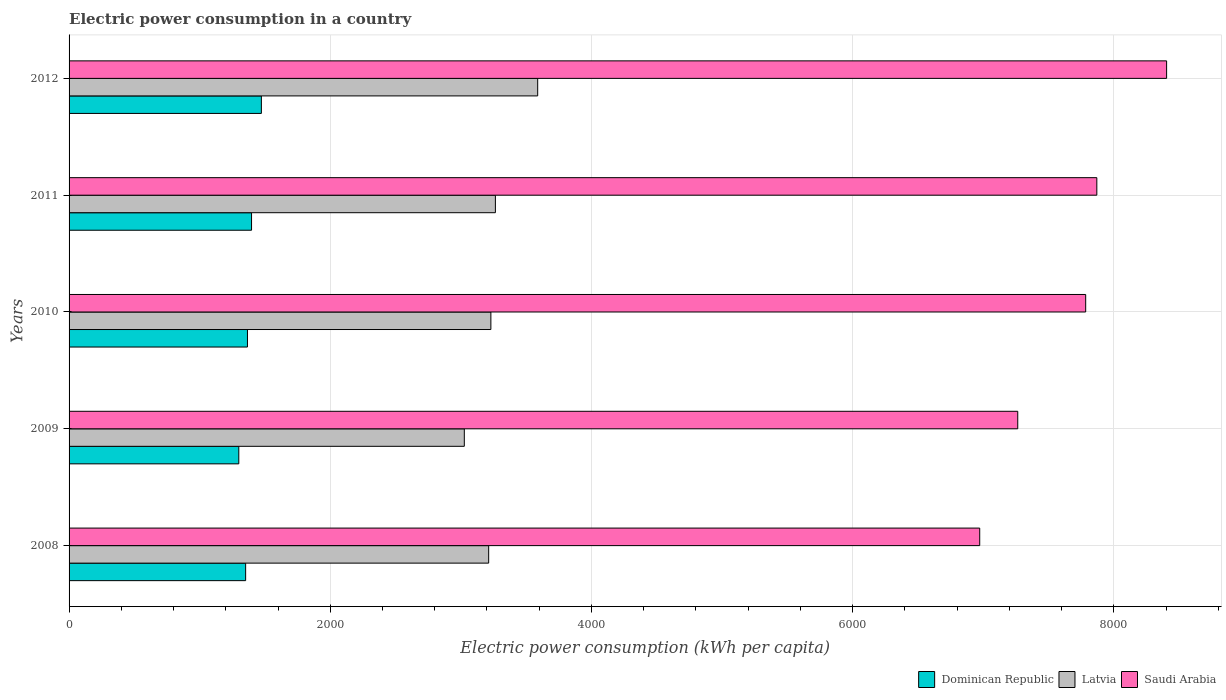How many bars are there on the 4th tick from the top?
Provide a short and direct response. 3. What is the electric power consumption in in Latvia in 2009?
Provide a short and direct response. 3026.61. Across all years, what is the maximum electric power consumption in in Latvia?
Your answer should be compact. 3588.42. Across all years, what is the minimum electric power consumption in in Saudi Arabia?
Your answer should be compact. 6973.38. What is the total electric power consumption in in Latvia in the graph?
Offer a very short reply. 1.63e+04. What is the difference between the electric power consumption in in Dominican Republic in 2010 and that in 2011?
Offer a very short reply. -31.27. What is the difference between the electric power consumption in in Latvia in 2010 and the electric power consumption in in Dominican Republic in 2008?
Your answer should be very brief. 1877.8. What is the average electric power consumption in in Latvia per year?
Your answer should be compact. 3264.53. In the year 2009, what is the difference between the electric power consumption in in Latvia and electric power consumption in in Dominican Republic?
Give a very brief answer. 1726.92. In how many years, is the electric power consumption in in Saudi Arabia greater than 4800 kWh per capita?
Your response must be concise. 5. What is the ratio of the electric power consumption in in Dominican Republic in 2009 to that in 2010?
Give a very brief answer. 0.95. Is the difference between the electric power consumption in in Latvia in 2010 and 2011 greater than the difference between the electric power consumption in in Dominican Republic in 2010 and 2011?
Your answer should be very brief. No. What is the difference between the highest and the second highest electric power consumption in in Dominican Republic?
Your response must be concise. 75.26. What is the difference between the highest and the lowest electric power consumption in in Dominican Republic?
Provide a succinct answer. 172.88. In how many years, is the electric power consumption in in Dominican Republic greater than the average electric power consumption in in Dominican Republic taken over all years?
Give a very brief answer. 2. What does the 3rd bar from the top in 2011 represents?
Provide a succinct answer. Dominican Republic. What does the 3rd bar from the bottom in 2008 represents?
Offer a very short reply. Saudi Arabia. Is it the case that in every year, the sum of the electric power consumption in in Dominican Republic and electric power consumption in in Saudi Arabia is greater than the electric power consumption in in Latvia?
Your response must be concise. Yes. Are the values on the major ticks of X-axis written in scientific E-notation?
Your response must be concise. No. Does the graph contain any zero values?
Provide a short and direct response. No. Where does the legend appear in the graph?
Ensure brevity in your answer.  Bottom right. How many legend labels are there?
Your response must be concise. 3. How are the legend labels stacked?
Your response must be concise. Horizontal. What is the title of the graph?
Ensure brevity in your answer.  Electric power consumption in a country. Does "Switzerland" appear as one of the legend labels in the graph?
Your response must be concise. No. What is the label or title of the X-axis?
Provide a short and direct response. Electric power consumption (kWh per capita). What is the Electric power consumption (kWh per capita) in Dominican Republic in 2008?
Make the answer very short. 1352.15. What is the Electric power consumption (kWh per capita) of Latvia in 2008?
Your answer should be very brief. 3213.12. What is the Electric power consumption (kWh per capita) in Saudi Arabia in 2008?
Offer a terse response. 6973.38. What is the Electric power consumption (kWh per capita) of Dominican Republic in 2009?
Offer a very short reply. 1299.69. What is the Electric power consumption (kWh per capita) of Latvia in 2009?
Give a very brief answer. 3026.61. What is the Electric power consumption (kWh per capita) of Saudi Arabia in 2009?
Offer a terse response. 7264.53. What is the Electric power consumption (kWh per capita) in Dominican Republic in 2010?
Give a very brief answer. 1366.04. What is the Electric power consumption (kWh per capita) of Latvia in 2010?
Keep it short and to the point. 3229.95. What is the Electric power consumption (kWh per capita) of Saudi Arabia in 2010?
Ensure brevity in your answer.  7784.76. What is the Electric power consumption (kWh per capita) of Dominican Republic in 2011?
Make the answer very short. 1397.31. What is the Electric power consumption (kWh per capita) of Latvia in 2011?
Give a very brief answer. 3264.54. What is the Electric power consumption (kWh per capita) of Saudi Arabia in 2011?
Provide a short and direct response. 7870.14. What is the Electric power consumption (kWh per capita) of Dominican Republic in 2012?
Provide a short and direct response. 1472.57. What is the Electric power consumption (kWh per capita) of Latvia in 2012?
Your response must be concise. 3588.42. What is the Electric power consumption (kWh per capita) of Saudi Arabia in 2012?
Your answer should be very brief. 8404.52. Across all years, what is the maximum Electric power consumption (kWh per capita) in Dominican Republic?
Make the answer very short. 1472.57. Across all years, what is the maximum Electric power consumption (kWh per capita) in Latvia?
Your answer should be very brief. 3588.42. Across all years, what is the maximum Electric power consumption (kWh per capita) in Saudi Arabia?
Provide a short and direct response. 8404.52. Across all years, what is the minimum Electric power consumption (kWh per capita) in Dominican Republic?
Provide a succinct answer. 1299.69. Across all years, what is the minimum Electric power consumption (kWh per capita) in Latvia?
Make the answer very short. 3026.61. Across all years, what is the minimum Electric power consumption (kWh per capita) of Saudi Arabia?
Provide a short and direct response. 6973.38. What is the total Electric power consumption (kWh per capita) of Dominican Republic in the graph?
Make the answer very short. 6887.75. What is the total Electric power consumption (kWh per capita) in Latvia in the graph?
Offer a terse response. 1.63e+04. What is the total Electric power consumption (kWh per capita) of Saudi Arabia in the graph?
Keep it short and to the point. 3.83e+04. What is the difference between the Electric power consumption (kWh per capita) of Dominican Republic in 2008 and that in 2009?
Offer a terse response. 52.47. What is the difference between the Electric power consumption (kWh per capita) of Latvia in 2008 and that in 2009?
Provide a succinct answer. 186.51. What is the difference between the Electric power consumption (kWh per capita) of Saudi Arabia in 2008 and that in 2009?
Offer a terse response. -291.15. What is the difference between the Electric power consumption (kWh per capita) in Dominican Republic in 2008 and that in 2010?
Provide a short and direct response. -13.88. What is the difference between the Electric power consumption (kWh per capita) of Latvia in 2008 and that in 2010?
Ensure brevity in your answer.  -16.83. What is the difference between the Electric power consumption (kWh per capita) of Saudi Arabia in 2008 and that in 2010?
Your answer should be very brief. -811.38. What is the difference between the Electric power consumption (kWh per capita) in Dominican Republic in 2008 and that in 2011?
Provide a succinct answer. -45.16. What is the difference between the Electric power consumption (kWh per capita) of Latvia in 2008 and that in 2011?
Give a very brief answer. -51.42. What is the difference between the Electric power consumption (kWh per capita) in Saudi Arabia in 2008 and that in 2011?
Provide a succinct answer. -896.76. What is the difference between the Electric power consumption (kWh per capita) in Dominican Republic in 2008 and that in 2012?
Make the answer very short. -120.42. What is the difference between the Electric power consumption (kWh per capita) of Latvia in 2008 and that in 2012?
Offer a very short reply. -375.3. What is the difference between the Electric power consumption (kWh per capita) in Saudi Arabia in 2008 and that in 2012?
Provide a succinct answer. -1431.14. What is the difference between the Electric power consumption (kWh per capita) in Dominican Republic in 2009 and that in 2010?
Provide a short and direct response. -66.35. What is the difference between the Electric power consumption (kWh per capita) in Latvia in 2009 and that in 2010?
Keep it short and to the point. -203.34. What is the difference between the Electric power consumption (kWh per capita) in Saudi Arabia in 2009 and that in 2010?
Keep it short and to the point. -520.23. What is the difference between the Electric power consumption (kWh per capita) of Dominican Republic in 2009 and that in 2011?
Provide a short and direct response. -97.62. What is the difference between the Electric power consumption (kWh per capita) in Latvia in 2009 and that in 2011?
Offer a very short reply. -237.93. What is the difference between the Electric power consumption (kWh per capita) of Saudi Arabia in 2009 and that in 2011?
Your answer should be very brief. -605.61. What is the difference between the Electric power consumption (kWh per capita) in Dominican Republic in 2009 and that in 2012?
Offer a terse response. -172.88. What is the difference between the Electric power consumption (kWh per capita) of Latvia in 2009 and that in 2012?
Make the answer very short. -561.81. What is the difference between the Electric power consumption (kWh per capita) of Saudi Arabia in 2009 and that in 2012?
Keep it short and to the point. -1139.99. What is the difference between the Electric power consumption (kWh per capita) of Dominican Republic in 2010 and that in 2011?
Offer a terse response. -31.27. What is the difference between the Electric power consumption (kWh per capita) of Latvia in 2010 and that in 2011?
Make the answer very short. -34.59. What is the difference between the Electric power consumption (kWh per capita) in Saudi Arabia in 2010 and that in 2011?
Your answer should be compact. -85.38. What is the difference between the Electric power consumption (kWh per capita) in Dominican Republic in 2010 and that in 2012?
Offer a very short reply. -106.53. What is the difference between the Electric power consumption (kWh per capita) in Latvia in 2010 and that in 2012?
Your answer should be very brief. -358.47. What is the difference between the Electric power consumption (kWh per capita) in Saudi Arabia in 2010 and that in 2012?
Make the answer very short. -619.75. What is the difference between the Electric power consumption (kWh per capita) in Dominican Republic in 2011 and that in 2012?
Make the answer very short. -75.26. What is the difference between the Electric power consumption (kWh per capita) in Latvia in 2011 and that in 2012?
Provide a short and direct response. -323.89. What is the difference between the Electric power consumption (kWh per capita) of Saudi Arabia in 2011 and that in 2012?
Give a very brief answer. -534.38. What is the difference between the Electric power consumption (kWh per capita) in Dominican Republic in 2008 and the Electric power consumption (kWh per capita) in Latvia in 2009?
Your answer should be compact. -1674.46. What is the difference between the Electric power consumption (kWh per capita) of Dominican Republic in 2008 and the Electric power consumption (kWh per capita) of Saudi Arabia in 2009?
Your answer should be compact. -5912.38. What is the difference between the Electric power consumption (kWh per capita) in Latvia in 2008 and the Electric power consumption (kWh per capita) in Saudi Arabia in 2009?
Keep it short and to the point. -4051.41. What is the difference between the Electric power consumption (kWh per capita) of Dominican Republic in 2008 and the Electric power consumption (kWh per capita) of Latvia in 2010?
Offer a very short reply. -1877.8. What is the difference between the Electric power consumption (kWh per capita) in Dominican Republic in 2008 and the Electric power consumption (kWh per capita) in Saudi Arabia in 2010?
Make the answer very short. -6432.61. What is the difference between the Electric power consumption (kWh per capita) of Latvia in 2008 and the Electric power consumption (kWh per capita) of Saudi Arabia in 2010?
Your answer should be very brief. -4571.64. What is the difference between the Electric power consumption (kWh per capita) of Dominican Republic in 2008 and the Electric power consumption (kWh per capita) of Latvia in 2011?
Keep it short and to the point. -1912.39. What is the difference between the Electric power consumption (kWh per capita) in Dominican Republic in 2008 and the Electric power consumption (kWh per capita) in Saudi Arabia in 2011?
Make the answer very short. -6517.99. What is the difference between the Electric power consumption (kWh per capita) of Latvia in 2008 and the Electric power consumption (kWh per capita) of Saudi Arabia in 2011?
Keep it short and to the point. -4657.02. What is the difference between the Electric power consumption (kWh per capita) in Dominican Republic in 2008 and the Electric power consumption (kWh per capita) in Latvia in 2012?
Make the answer very short. -2236.27. What is the difference between the Electric power consumption (kWh per capita) in Dominican Republic in 2008 and the Electric power consumption (kWh per capita) in Saudi Arabia in 2012?
Keep it short and to the point. -7052.36. What is the difference between the Electric power consumption (kWh per capita) in Latvia in 2008 and the Electric power consumption (kWh per capita) in Saudi Arabia in 2012?
Make the answer very short. -5191.39. What is the difference between the Electric power consumption (kWh per capita) in Dominican Republic in 2009 and the Electric power consumption (kWh per capita) in Latvia in 2010?
Give a very brief answer. -1930.26. What is the difference between the Electric power consumption (kWh per capita) of Dominican Republic in 2009 and the Electric power consumption (kWh per capita) of Saudi Arabia in 2010?
Give a very brief answer. -6485.07. What is the difference between the Electric power consumption (kWh per capita) in Latvia in 2009 and the Electric power consumption (kWh per capita) in Saudi Arabia in 2010?
Offer a terse response. -4758.15. What is the difference between the Electric power consumption (kWh per capita) in Dominican Republic in 2009 and the Electric power consumption (kWh per capita) in Latvia in 2011?
Your answer should be compact. -1964.85. What is the difference between the Electric power consumption (kWh per capita) in Dominican Republic in 2009 and the Electric power consumption (kWh per capita) in Saudi Arabia in 2011?
Your answer should be compact. -6570.45. What is the difference between the Electric power consumption (kWh per capita) of Latvia in 2009 and the Electric power consumption (kWh per capita) of Saudi Arabia in 2011?
Provide a succinct answer. -4843.53. What is the difference between the Electric power consumption (kWh per capita) of Dominican Republic in 2009 and the Electric power consumption (kWh per capita) of Latvia in 2012?
Your answer should be very brief. -2288.74. What is the difference between the Electric power consumption (kWh per capita) in Dominican Republic in 2009 and the Electric power consumption (kWh per capita) in Saudi Arabia in 2012?
Your response must be concise. -7104.83. What is the difference between the Electric power consumption (kWh per capita) in Latvia in 2009 and the Electric power consumption (kWh per capita) in Saudi Arabia in 2012?
Ensure brevity in your answer.  -5377.9. What is the difference between the Electric power consumption (kWh per capita) in Dominican Republic in 2010 and the Electric power consumption (kWh per capita) in Latvia in 2011?
Your response must be concise. -1898.5. What is the difference between the Electric power consumption (kWh per capita) in Dominican Republic in 2010 and the Electric power consumption (kWh per capita) in Saudi Arabia in 2011?
Your answer should be very brief. -6504.1. What is the difference between the Electric power consumption (kWh per capita) in Latvia in 2010 and the Electric power consumption (kWh per capita) in Saudi Arabia in 2011?
Offer a terse response. -4640.19. What is the difference between the Electric power consumption (kWh per capita) in Dominican Republic in 2010 and the Electric power consumption (kWh per capita) in Latvia in 2012?
Your answer should be very brief. -2222.39. What is the difference between the Electric power consumption (kWh per capita) in Dominican Republic in 2010 and the Electric power consumption (kWh per capita) in Saudi Arabia in 2012?
Your answer should be compact. -7038.48. What is the difference between the Electric power consumption (kWh per capita) in Latvia in 2010 and the Electric power consumption (kWh per capita) in Saudi Arabia in 2012?
Your answer should be very brief. -5174.56. What is the difference between the Electric power consumption (kWh per capita) of Dominican Republic in 2011 and the Electric power consumption (kWh per capita) of Latvia in 2012?
Keep it short and to the point. -2191.12. What is the difference between the Electric power consumption (kWh per capita) in Dominican Republic in 2011 and the Electric power consumption (kWh per capita) in Saudi Arabia in 2012?
Your response must be concise. -7007.21. What is the difference between the Electric power consumption (kWh per capita) of Latvia in 2011 and the Electric power consumption (kWh per capita) of Saudi Arabia in 2012?
Offer a terse response. -5139.98. What is the average Electric power consumption (kWh per capita) of Dominican Republic per year?
Make the answer very short. 1377.55. What is the average Electric power consumption (kWh per capita) of Latvia per year?
Your answer should be very brief. 3264.53. What is the average Electric power consumption (kWh per capita) of Saudi Arabia per year?
Provide a short and direct response. 7659.46. In the year 2008, what is the difference between the Electric power consumption (kWh per capita) in Dominican Republic and Electric power consumption (kWh per capita) in Latvia?
Provide a succinct answer. -1860.97. In the year 2008, what is the difference between the Electric power consumption (kWh per capita) of Dominican Republic and Electric power consumption (kWh per capita) of Saudi Arabia?
Your answer should be compact. -5621.23. In the year 2008, what is the difference between the Electric power consumption (kWh per capita) in Latvia and Electric power consumption (kWh per capita) in Saudi Arabia?
Your answer should be very brief. -3760.26. In the year 2009, what is the difference between the Electric power consumption (kWh per capita) of Dominican Republic and Electric power consumption (kWh per capita) of Latvia?
Your response must be concise. -1726.92. In the year 2009, what is the difference between the Electric power consumption (kWh per capita) in Dominican Republic and Electric power consumption (kWh per capita) in Saudi Arabia?
Ensure brevity in your answer.  -5964.84. In the year 2009, what is the difference between the Electric power consumption (kWh per capita) in Latvia and Electric power consumption (kWh per capita) in Saudi Arabia?
Your answer should be compact. -4237.92. In the year 2010, what is the difference between the Electric power consumption (kWh per capita) in Dominican Republic and Electric power consumption (kWh per capita) in Latvia?
Offer a terse response. -1863.92. In the year 2010, what is the difference between the Electric power consumption (kWh per capita) of Dominican Republic and Electric power consumption (kWh per capita) of Saudi Arabia?
Keep it short and to the point. -6418.73. In the year 2010, what is the difference between the Electric power consumption (kWh per capita) of Latvia and Electric power consumption (kWh per capita) of Saudi Arabia?
Make the answer very short. -4554.81. In the year 2011, what is the difference between the Electric power consumption (kWh per capita) of Dominican Republic and Electric power consumption (kWh per capita) of Latvia?
Provide a succinct answer. -1867.23. In the year 2011, what is the difference between the Electric power consumption (kWh per capita) in Dominican Republic and Electric power consumption (kWh per capita) in Saudi Arabia?
Offer a terse response. -6472.83. In the year 2011, what is the difference between the Electric power consumption (kWh per capita) of Latvia and Electric power consumption (kWh per capita) of Saudi Arabia?
Offer a terse response. -4605.6. In the year 2012, what is the difference between the Electric power consumption (kWh per capita) in Dominican Republic and Electric power consumption (kWh per capita) in Latvia?
Make the answer very short. -2115.85. In the year 2012, what is the difference between the Electric power consumption (kWh per capita) in Dominican Republic and Electric power consumption (kWh per capita) in Saudi Arabia?
Keep it short and to the point. -6931.95. In the year 2012, what is the difference between the Electric power consumption (kWh per capita) in Latvia and Electric power consumption (kWh per capita) in Saudi Arabia?
Give a very brief answer. -4816.09. What is the ratio of the Electric power consumption (kWh per capita) of Dominican Republic in 2008 to that in 2009?
Your answer should be very brief. 1.04. What is the ratio of the Electric power consumption (kWh per capita) of Latvia in 2008 to that in 2009?
Your answer should be very brief. 1.06. What is the ratio of the Electric power consumption (kWh per capita) of Saudi Arabia in 2008 to that in 2009?
Provide a succinct answer. 0.96. What is the ratio of the Electric power consumption (kWh per capita) in Dominican Republic in 2008 to that in 2010?
Your response must be concise. 0.99. What is the ratio of the Electric power consumption (kWh per capita) of Latvia in 2008 to that in 2010?
Provide a succinct answer. 0.99. What is the ratio of the Electric power consumption (kWh per capita) of Saudi Arabia in 2008 to that in 2010?
Ensure brevity in your answer.  0.9. What is the ratio of the Electric power consumption (kWh per capita) in Latvia in 2008 to that in 2011?
Give a very brief answer. 0.98. What is the ratio of the Electric power consumption (kWh per capita) of Saudi Arabia in 2008 to that in 2011?
Your answer should be very brief. 0.89. What is the ratio of the Electric power consumption (kWh per capita) in Dominican Republic in 2008 to that in 2012?
Offer a terse response. 0.92. What is the ratio of the Electric power consumption (kWh per capita) in Latvia in 2008 to that in 2012?
Provide a succinct answer. 0.9. What is the ratio of the Electric power consumption (kWh per capita) of Saudi Arabia in 2008 to that in 2012?
Provide a short and direct response. 0.83. What is the ratio of the Electric power consumption (kWh per capita) of Dominican Republic in 2009 to that in 2010?
Provide a short and direct response. 0.95. What is the ratio of the Electric power consumption (kWh per capita) of Latvia in 2009 to that in 2010?
Your response must be concise. 0.94. What is the ratio of the Electric power consumption (kWh per capita) of Saudi Arabia in 2009 to that in 2010?
Make the answer very short. 0.93. What is the ratio of the Electric power consumption (kWh per capita) in Dominican Republic in 2009 to that in 2011?
Offer a terse response. 0.93. What is the ratio of the Electric power consumption (kWh per capita) of Latvia in 2009 to that in 2011?
Offer a terse response. 0.93. What is the ratio of the Electric power consumption (kWh per capita) of Saudi Arabia in 2009 to that in 2011?
Your answer should be compact. 0.92. What is the ratio of the Electric power consumption (kWh per capita) in Dominican Republic in 2009 to that in 2012?
Keep it short and to the point. 0.88. What is the ratio of the Electric power consumption (kWh per capita) of Latvia in 2009 to that in 2012?
Ensure brevity in your answer.  0.84. What is the ratio of the Electric power consumption (kWh per capita) of Saudi Arabia in 2009 to that in 2012?
Keep it short and to the point. 0.86. What is the ratio of the Electric power consumption (kWh per capita) of Dominican Republic in 2010 to that in 2011?
Your answer should be compact. 0.98. What is the ratio of the Electric power consumption (kWh per capita) in Saudi Arabia in 2010 to that in 2011?
Your answer should be compact. 0.99. What is the ratio of the Electric power consumption (kWh per capita) in Dominican Republic in 2010 to that in 2012?
Give a very brief answer. 0.93. What is the ratio of the Electric power consumption (kWh per capita) in Latvia in 2010 to that in 2012?
Give a very brief answer. 0.9. What is the ratio of the Electric power consumption (kWh per capita) of Saudi Arabia in 2010 to that in 2012?
Offer a very short reply. 0.93. What is the ratio of the Electric power consumption (kWh per capita) in Dominican Republic in 2011 to that in 2012?
Keep it short and to the point. 0.95. What is the ratio of the Electric power consumption (kWh per capita) in Latvia in 2011 to that in 2012?
Your answer should be compact. 0.91. What is the ratio of the Electric power consumption (kWh per capita) of Saudi Arabia in 2011 to that in 2012?
Your response must be concise. 0.94. What is the difference between the highest and the second highest Electric power consumption (kWh per capita) of Dominican Republic?
Offer a very short reply. 75.26. What is the difference between the highest and the second highest Electric power consumption (kWh per capita) of Latvia?
Your response must be concise. 323.89. What is the difference between the highest and the second highest Electric power consumption (kWh per capita) of Saudi Arabia?
Ensure brevity in your answer.  534.38. What is the difference between the highest and the lowest Electric power consumption (kWh per capita) of Dominican Republic?
Provide a succinct answer. 172.88. What is the difference between the highest and the lowest Electric power consumption (kWh per capita) in Latvia?
Ensure brevity in your answer.  561.81. What is the difference between the highest and the lowest Electric power consumption (kWh per capita) of Saudi Arabia?
Your response must be concise. 1431.14. 